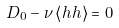Convert formula to latex. <formula><loc_0><loc_0><loc_500><loc_500>D _ { 0 } - \nu \left < h h \right > = 0</formula> 